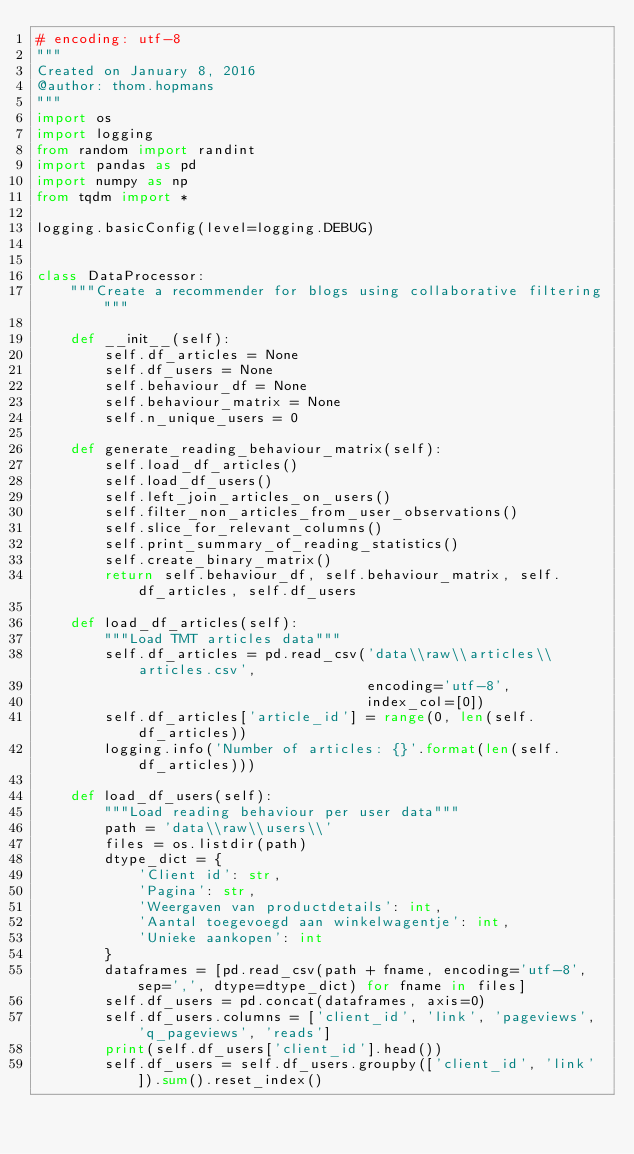<code> <loc_0><loc_0><loc_500><loc_500><_Python_># encoding: utf-8
"""
Created on January 8, 2016
@author: thom.hopmans
"""
import os
import logging
from random import randint
import pandas as pd
import numpy as np
from tqdm import *

logging.basicConfig(level=logging.DEBUG)


class DataProcessor:
    """Create a recommender for blogs using collaborative filtering"""

    def __init__(self):
        self.df_articles = None
        self.df_users = None
        self.behaviour_df = None
        self.behaviour_matrix = None
        self.n_unique_users = 0

    def generate_reading_behaviour_matrix(self):
        self.load_df_articles()
        self.load_df_users()
        self.left_join_articles_on_users()
        self.filter_non_articles_from_user_observations()
        self.slice_for_relevant_columns()
        self.print_summary_of_reading_statistics()
        self.create_binary_matrix()
        return self.behaviour_df, self.behaviour_matrix, self.df_articles, self.df_users

    def load_df_articles(self):
        """Load TMT articles data"""
        self.df_articles = pd.read_csv('data\\raw\\articles\\articles.csv',
                                       encoding='utf-8',
                                       index_col=[0])
        self.df_articles['article_id'] = range(0, len(self.df_articles))
        logging.info('Number of articles: {}'.format(len(self.df_articles)))

    def load_df_users(self):
        """Load reading behaviour per user data"""
        path = 'data\\raw\\users\\'
        files = os.listdir(path)
        dtype_dict = {
            'Client id': str,
            'Pagina': str,
            'Weergaven van productdetails': int,
            'Aantal toegevoegd aan winkelwagentje': int,
            'Unieke aankopen': int
        }
        dataframes = [pd.read_csv(path + fname, encoding='utf-8', sep=',', dtype=dtype_dict) for fname in files]
        self.df_users = pd.concat(dataframes, axis=0)
        self.df_users.columns = ['client_id', 'link', 'pageviews', 'q_pageviews', 'reads']
        print(self.df_users['client_id'].head())
        self.df_users = self.df_users.groupby(['client_id', 'link']).sum().reset_index()</code> 